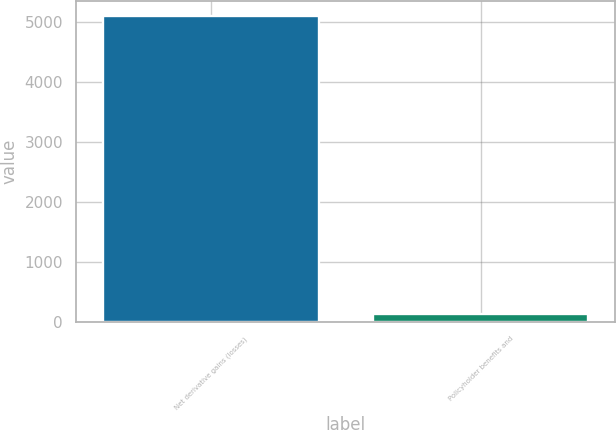Convert chart to OTSL. <chart><loc_0><loc_0><loc_500><loc_500><bar_chart><fcel>Net derivative gains (losses)<fcel>Policyholder benefits and<nl><fcel>5104<fcel>139<nl></chart> 